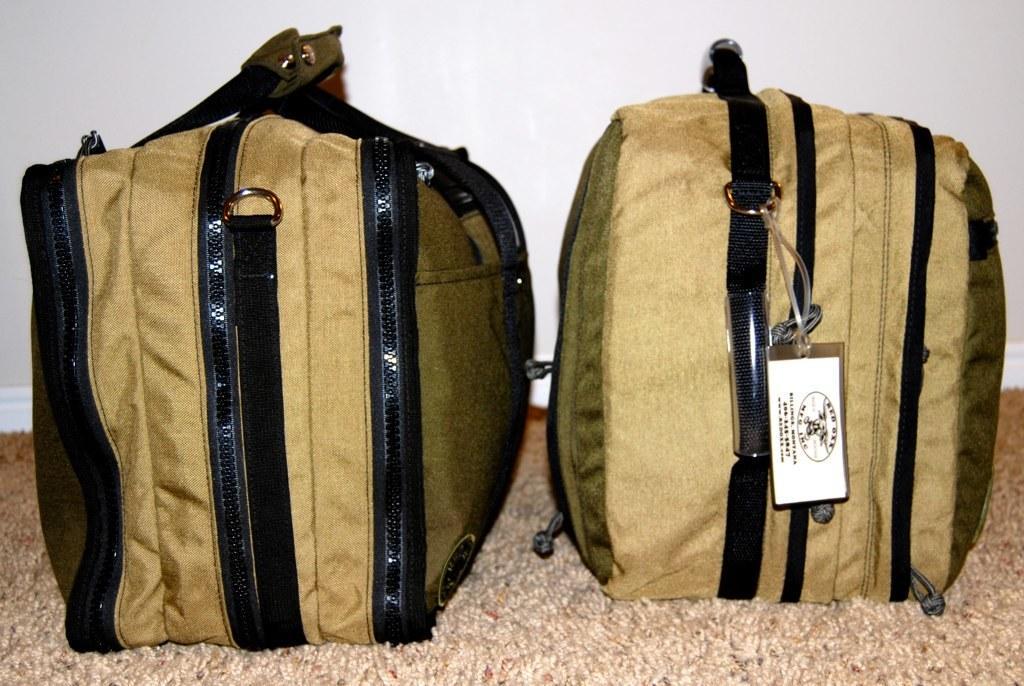Could you give a brief overview of what you see in this image? In this picture we can see baggage and a tag on the bag. 